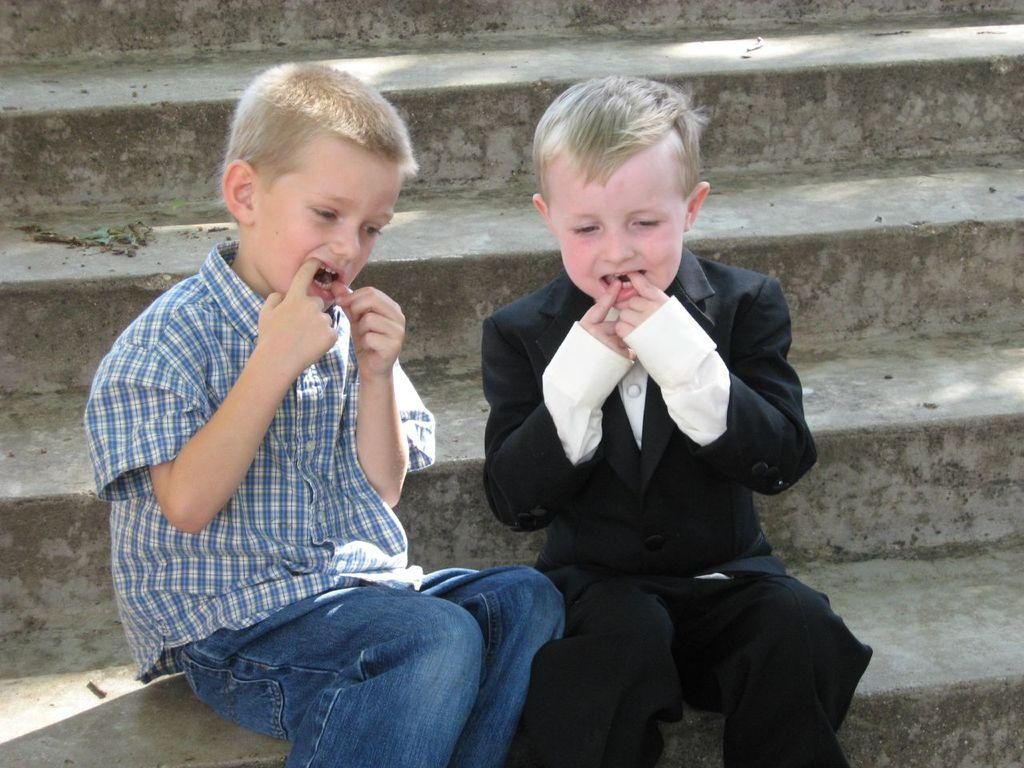How many kids are present in the image? There are two kids sitting in the center of the image. What can be seen in the background of the image? There is a staircase in the background of the image. What type of pot is the maid using to cook in the image? There is no pot or maid present in the image; it only features two kids sitting in the center and a staircase in the background. 